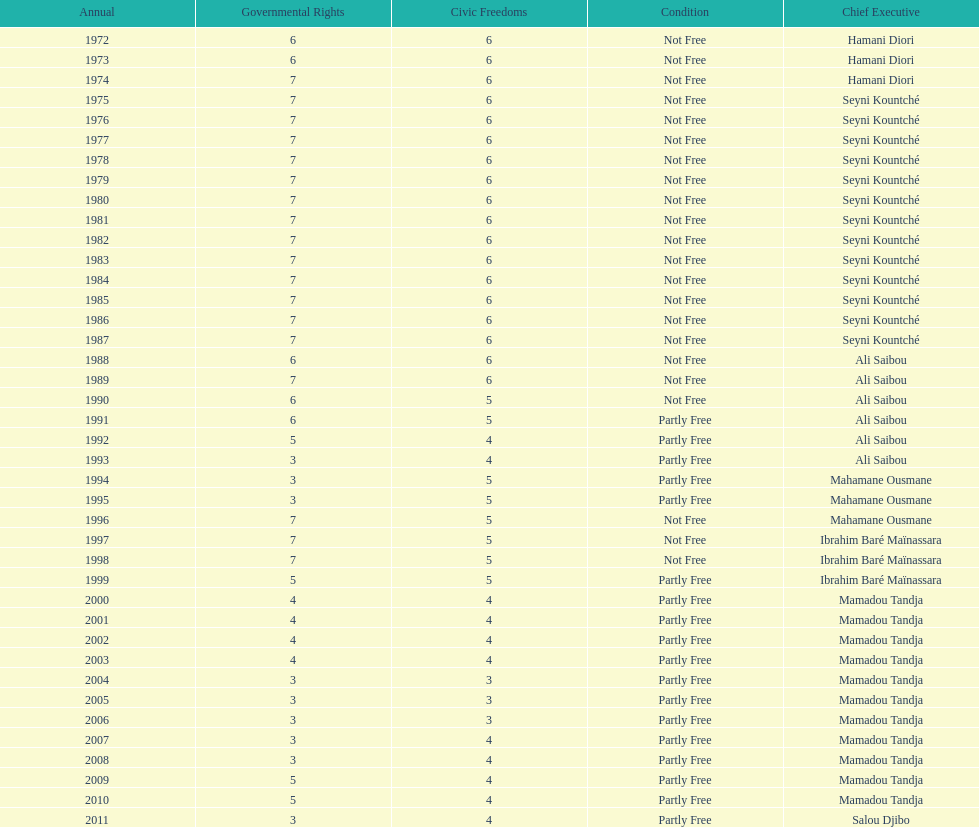Who is the next president listed after hamani diori in the year 1974? Seyni Kountché. 